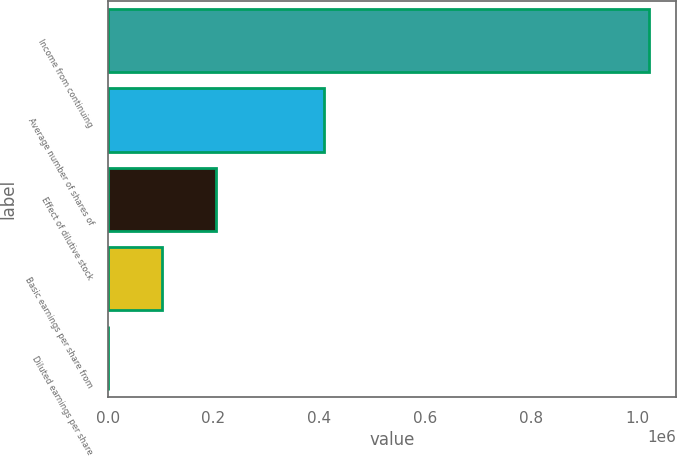Convert chart. <chart><loc_0><loc_0><loc_500><loc_500><bar_chart><fcel>Income from continuing<fcel>Average number of shares of<fcel>Effect of dilutive stock<fcel>Basic earnings per share from<fcel>Diluted earnings per share<nl><fcel>1.0234e+06<fcel>409363<fcel>204685<fcel>102345<fcel>6.42<nl></chart> 